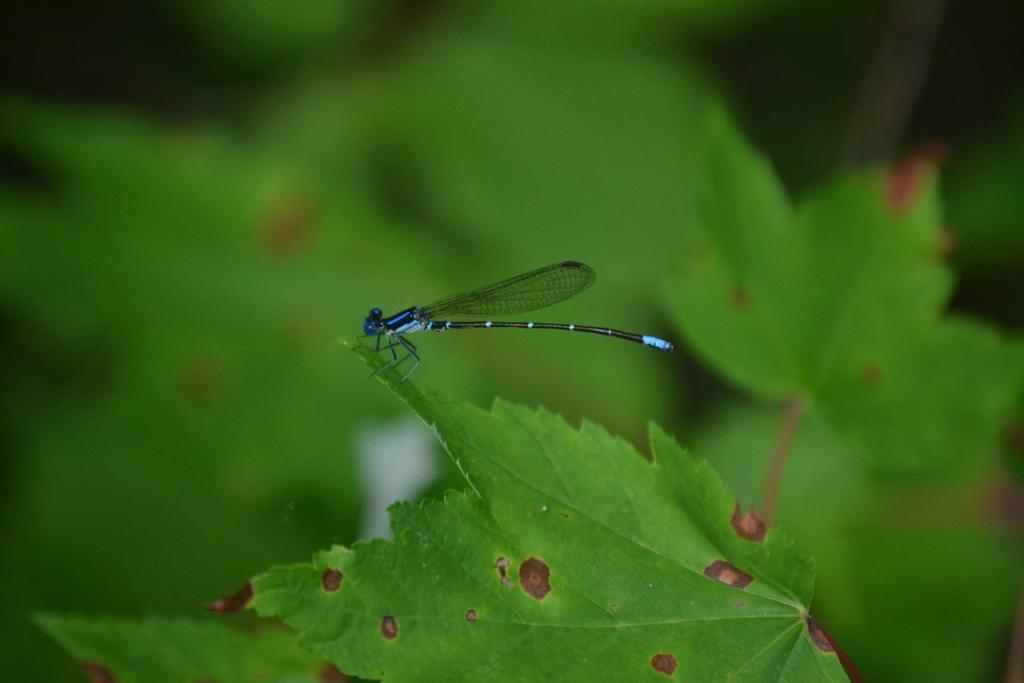Please provide a concise description of this image. In the middle of this image, there is an insect having wings, a tail and legs and standing on an edge of a green color leaf. And the background is blurred. 